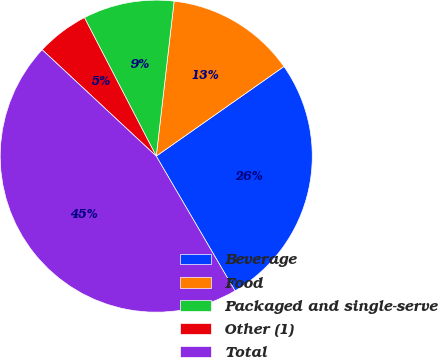<chart> <loc_0><loc_0><loc_500><loc_500><pie_chart><fcel>Beverage<fcel>Food<fcel>Packaged and single-serve<fcel>Other (1)<fcel>Total<nl><fcel>26.32%<fcel>13.43%<fcel>9.44%<fcel>5.44%<fcel>45.37%<nl></chart> 